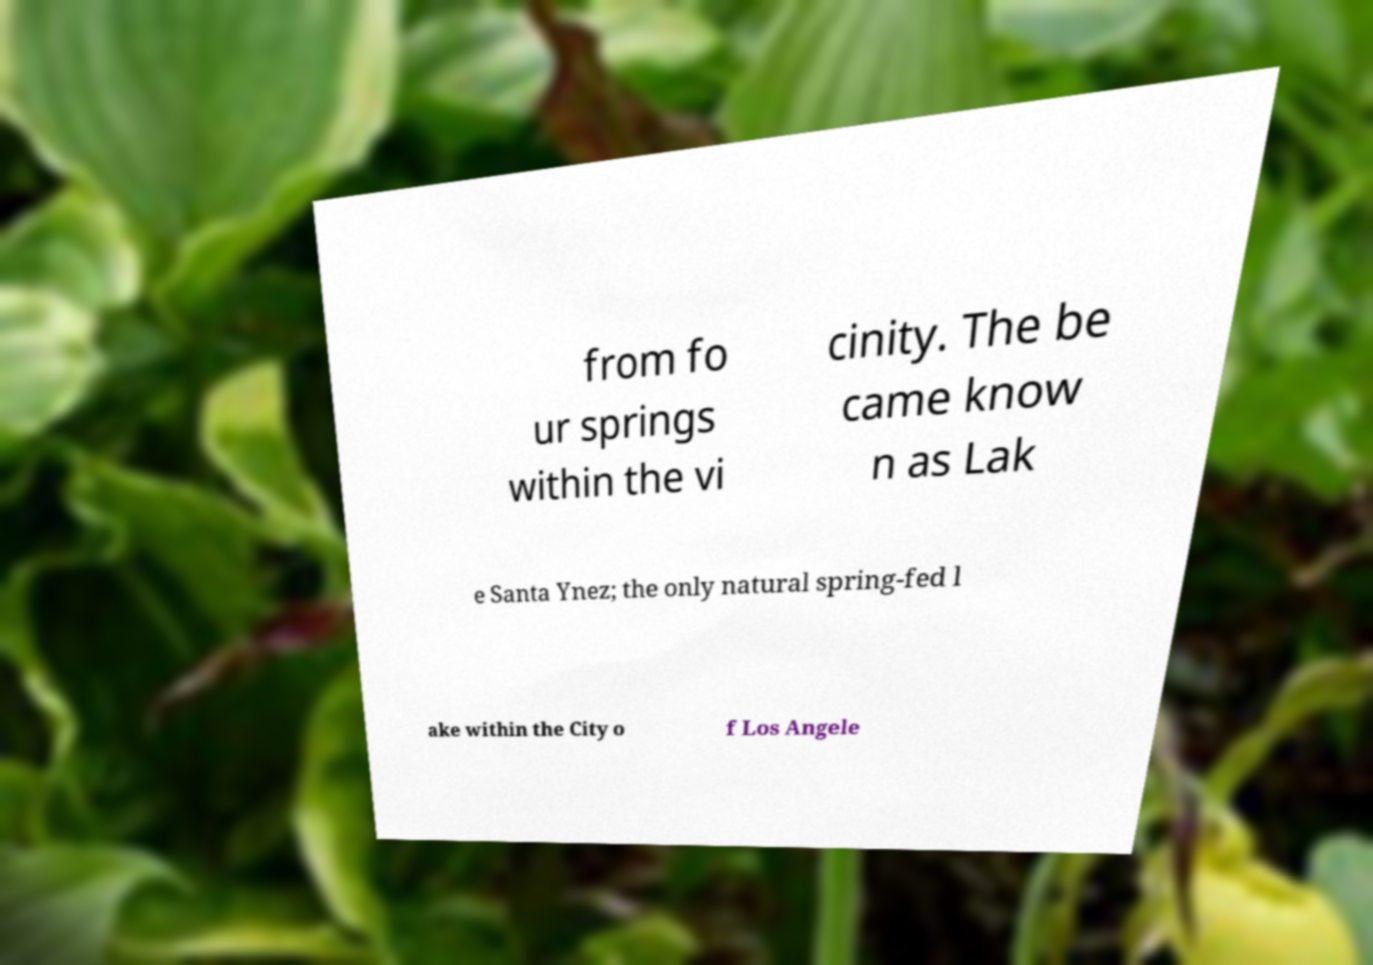Can you read and provide the text displayed in the image?This photo seems to have some interesting text. Can you extract and type it out for me? from fo ur springs within the vi cinity. The be came know n as Lak e Santa Ynez; the only natural spring-fed l ake within the City o f Los Angele 